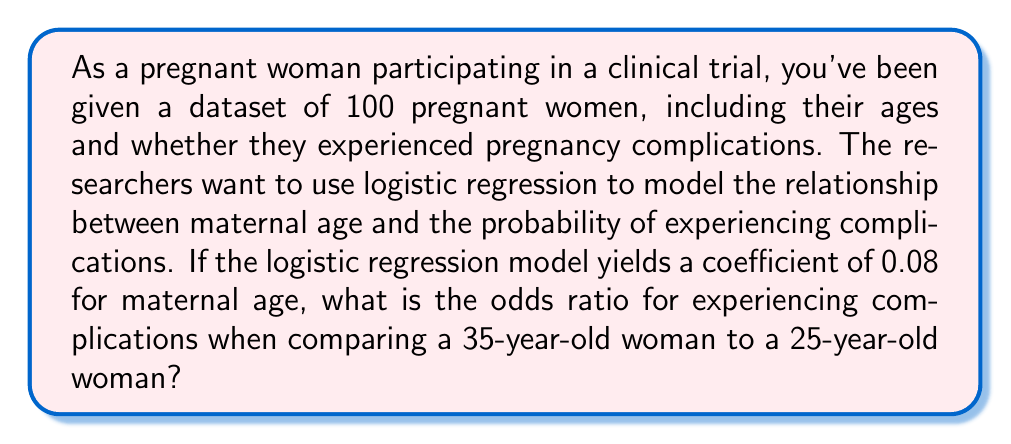Could you help me with this problem? Let's approach this step-by-step:

1) In logistic regression, the coefficient represents the change in the log-odds of the outcome for a one-unit increase in the predictor variable.

2) The odds ratio for a k-unit increase in the predictor variable is given by:

   $$\text{Odds Ratio} = e^{k\beta}$$

   where $\beta$ is the coefficient and $k$ is the number of units.

3) In this case, $\beta = 0.08$ and we're comparing a 10-year difference (35 vs 25), so $k = 10$.

4) Plugging these values into the formula:

   $$\text{Odds Ratio} = e^{10 * 0.08} = e^{0.8}$$

5) To calculate this:

   $$e^{0.8} \approx 2.2255$$

This means that the odds of experiencing complications for a 35-year-old woman are about 2.2255 times the odds for a 25-year-old woman, according to this model.
Answer: The odds ratio is approximately 2.2255. 